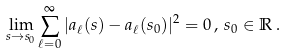Convert formula to latex. <formula><loc_0><loc_0><loc_500><loc_500>\lim _ { s \rightarrow s _ { 0 } } \sum _ { \ell = 0 } ^ { \infty } | a _ { \ell } ( s ) - a _ { \ell } ( s _ { 0 } ) | ^ { 2 } = 0 \, , \, s _ { 0 } \in \mathbb { R } \, .</formula> 